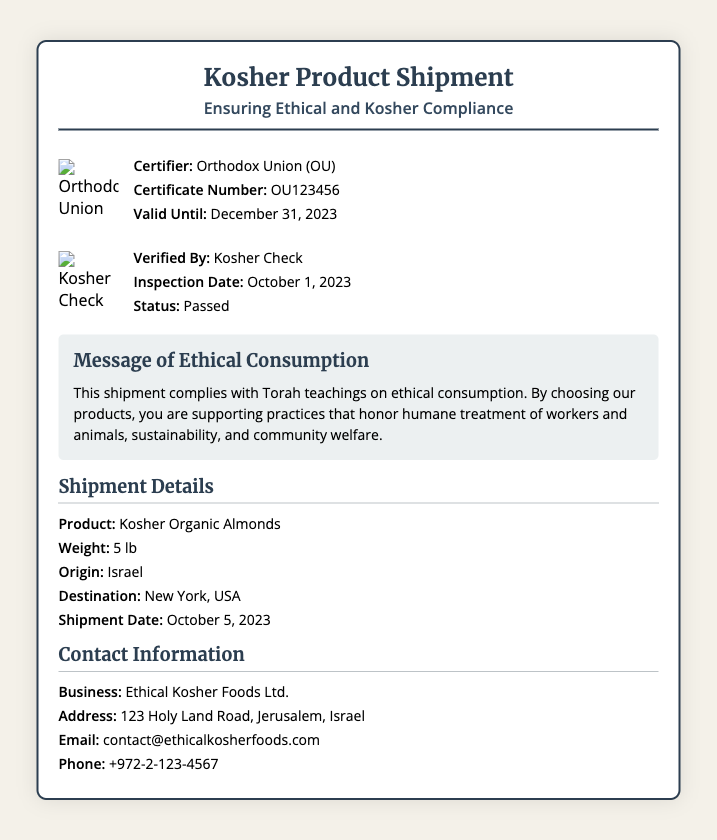What is the product being shipped? The document states the product name under the shipment details section.
Answer: Kosher Organic Almonds What is the weight of the shipment? The weight of the shipment is listed in the shipment details.
Answer: 5 lb What is the certification number? The certification number is provided in the certification section of the document.
Answer: OU123456 Who is the certifier? The name of the certifier is mentioned in the certification section.
Answer: Orthodox Union (OU) What is the inspection date? The inspection date is provided in the verification section of the document.
Answer: October 1, 2023 What is the destination of the shipment? The destination is mentioned in the shipment details.
Answer: New York, USA What message is included regarding ethical consumption? The document contains a message emphasizing ethical consumption principles.
Answer: This shipment complies with Torah teachings on ethical consumption Who verified the product? The verification section includes the name of the verifying organization.
Answer: Kosher Check When is the certification valid until? The validity date of the certification is specified in the certification section.
Answer: December 31, 2023 